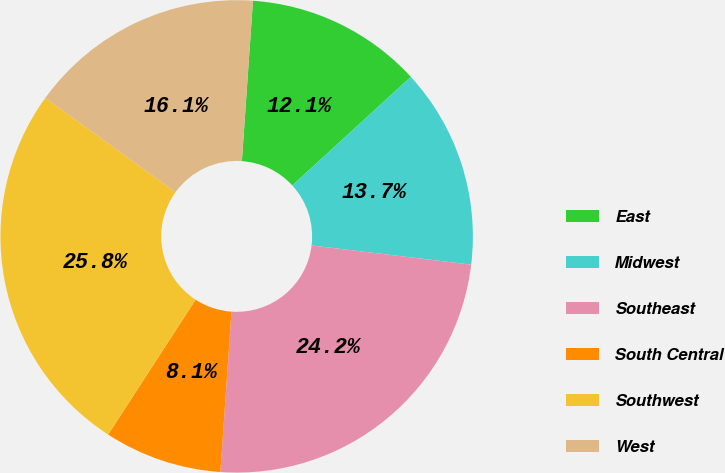Convert chart. <chart><loc_0><loc_0><loc_500><loc_500><pie_chart><fcel>East<fcel>Midwest<fcel>Southeast<fcel>South Central<fcel>Southwest<fcel>West<nl><fcel>12.1%<fcel>13.71%<fcel>24.19%<fcel>8.06%<fcel>25.81%<fcel>16.13%<nl></chart> 